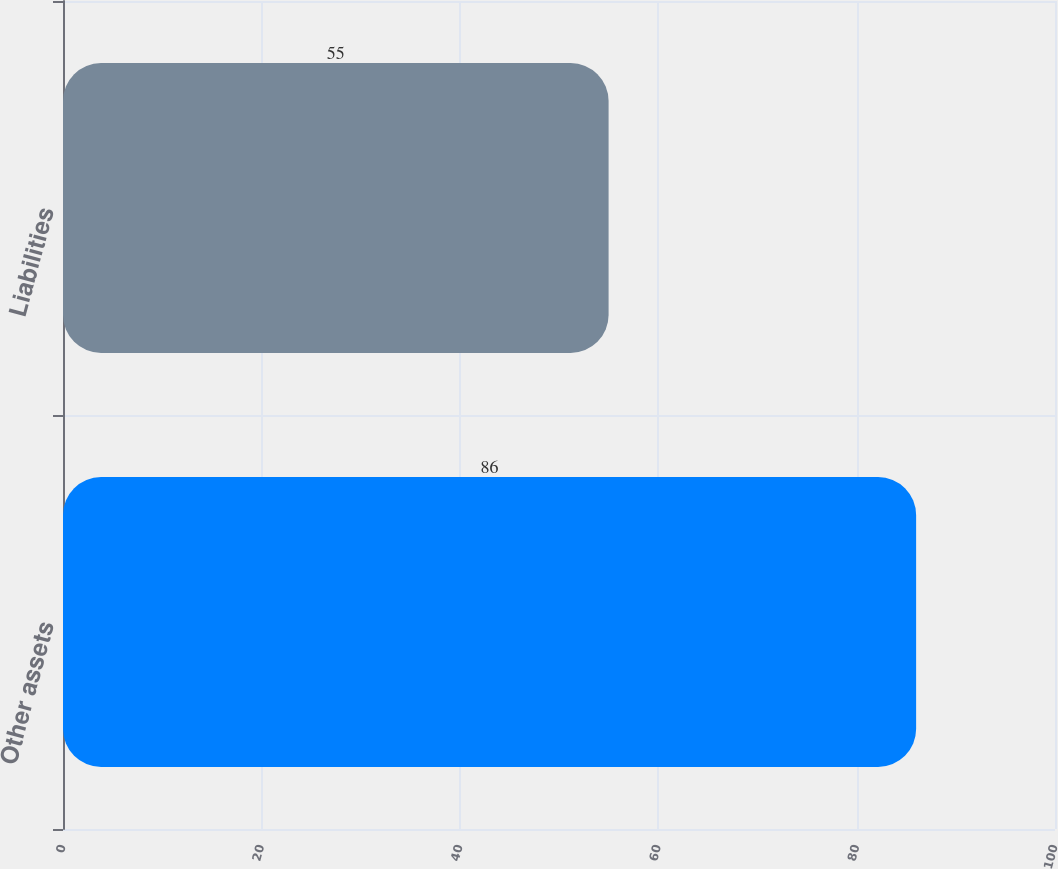<chart> <loc_0><loc_0><loc_500><loc_500><bar_chart><fcel>Other assets<fcel>Liabilities<nl><fcel>86<fcel>55<nl></chart> 